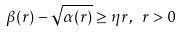<formula> <loc_0><loc_0><loc_500><loc_500>\beta ( r ) - \sqrt { \alpha ( r ) } \geq \eta r , \ r > 0</formula> 